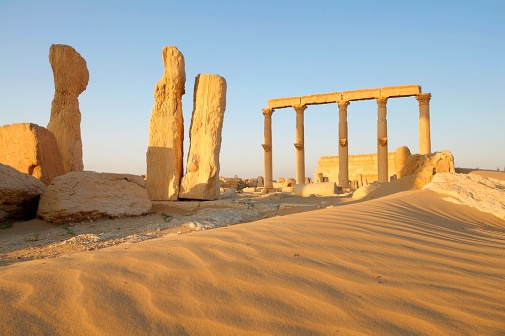Describe what you see in the image. The image shows an ancient temple set in a desert. There are six standing columns on the right side made of light-colored stone, and several other stone pieces scattered around. The ground is covered in golden sand, indicating a desert environment. The sky is a light blue, suggesting clear day weather. Can you imagine what this place would have looked like at its peak? At its peak, this temple would have been a beacon of architectural splendor amidst the desert landscape. The columns, in pristine condition, would rise majestically, supporting an elaborately decorated roof. The stonework would be adorned with intricate carvings and possibly painted in vivid colors. Lush greenery and perhaps a water source would contrast dramatically with the surrounding desert, making it a true oasis of civilization. 